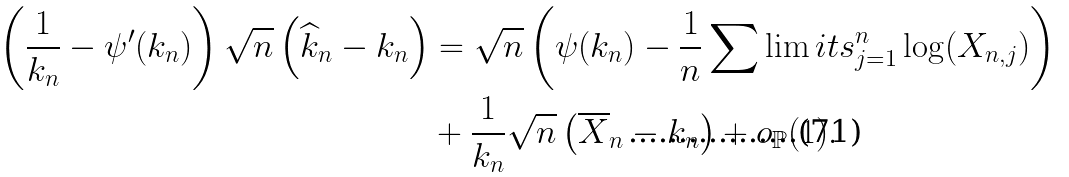<formula> <loc_0><loc_0><loc_500><loc_500>\left ( \frac { 1 } { k _ { n } } - \psi ^ { \prime } ( k _ { n } ) \right ) \sqrt { n } \left ( \widehat { k } _ { n } - k _ { n } \right ) & = \sqrt { n } \left ( \psi ( k _ { n } ) - \frac { 1 } { n } \sum \lim i t s _ { j = 1 } ^ { n } \log ( X _ { n , j } ) \right ) \\ & + \frac { 1 } { k _ { n } } \sqrt { n } \left ( \overline { X } _ { n } - k _ { n } \right ) + o _ { \mathbb { P } } ( 1 ) .</formula> 